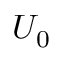Convert formula to latex. <formula><loc_0><loc_0><loc_500><loc_500>U _ { 0 }</formula> 